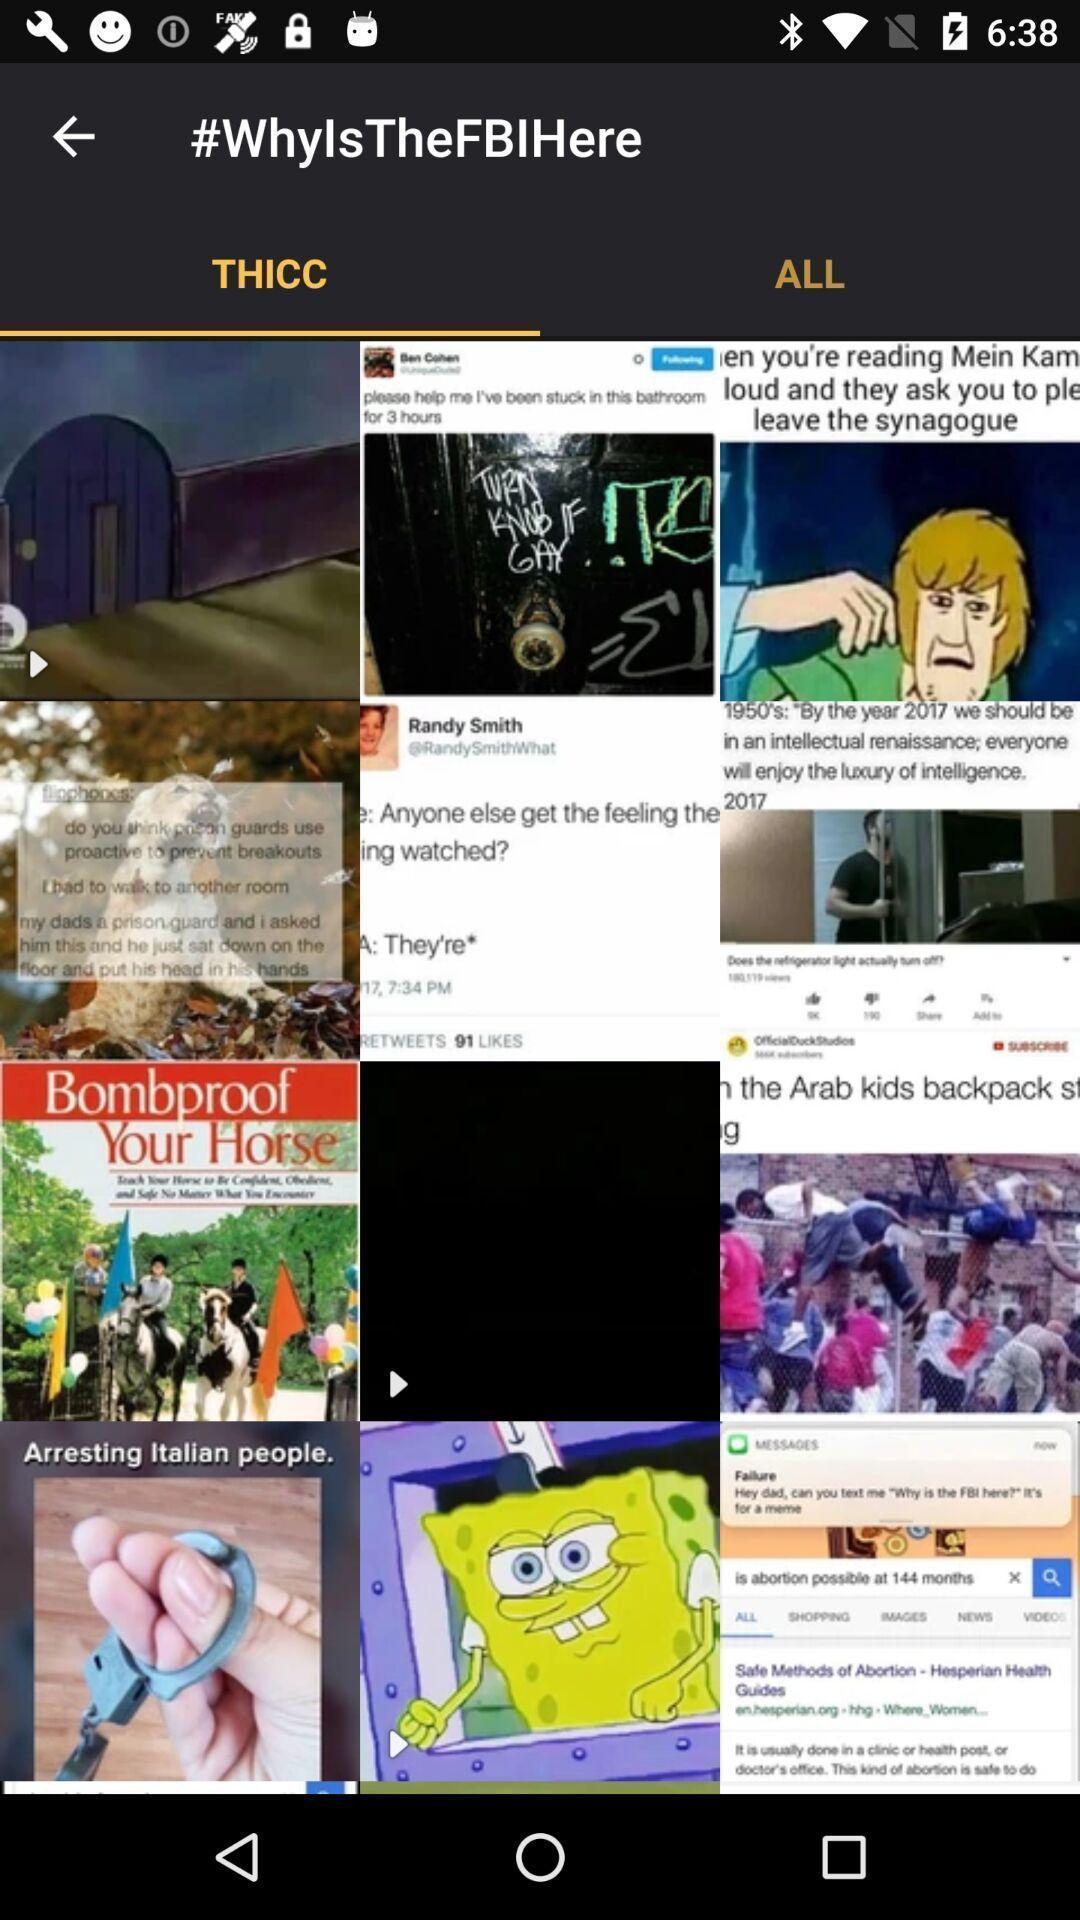Give me a summary of this screen capture. Page showing various images on app. 